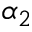Convert formula to latex. <formula><loc_0><loc_0><loc_500><loc_500>\alpha _ { 2 }</formula> 